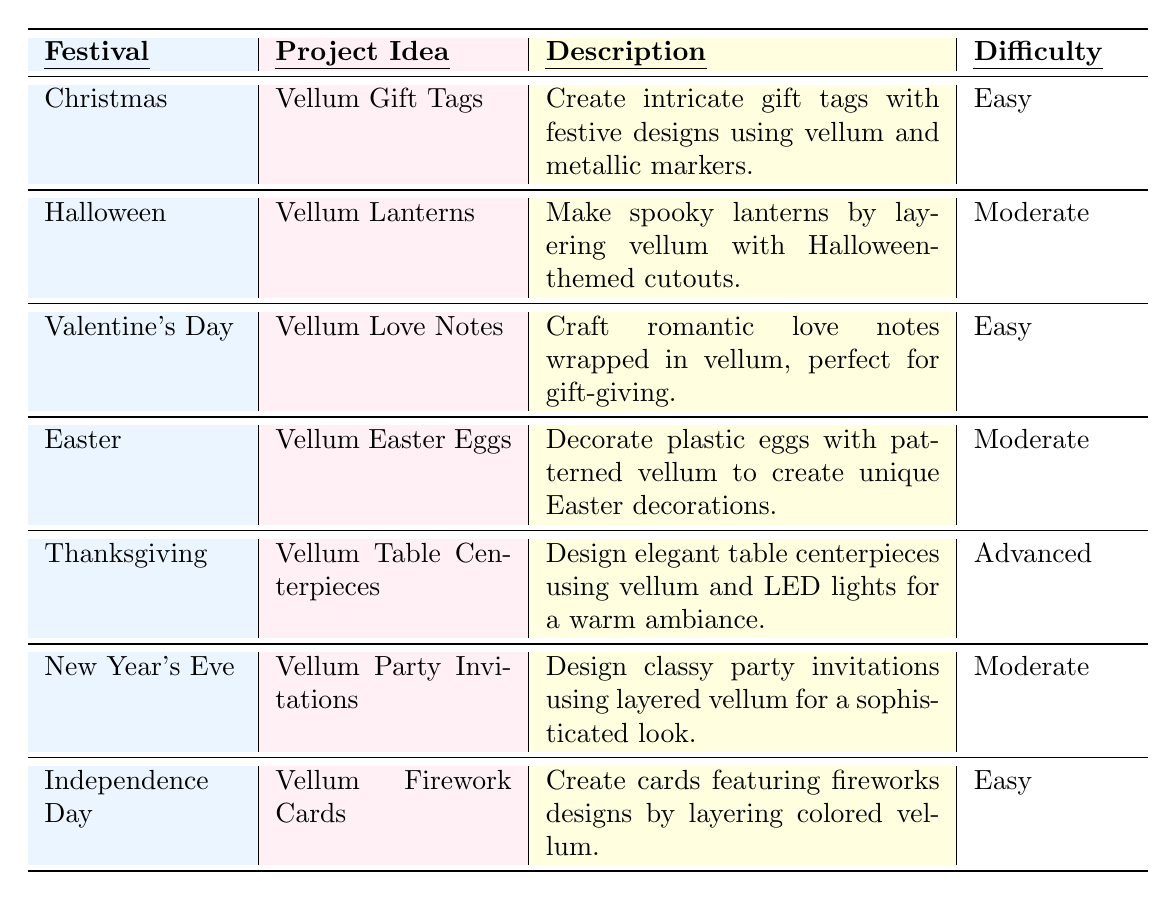What is the project idea for Christmas? The table lists "Vellum Gift Tags" as the project idea for Christmas.
Answer: Vellum Gift Tags Which festival has an advanced difficulty level project? The only project listed with an advanced difficulty level is "Vellum Table Centerpieces" for Thanksgiving.
Answer: Thanksgiving What materials are needed for Vellum Love Notes? The materials listed for Vellum Love Notes are colored vellum, cardstock, embellishments, and glue.
Answer: Colored vellum, cardstock, embellishments, glue How many projects are classified as easy? There are three projects classified as easy: Vellum Gift Tags for Christmas, Vellum Love Notes for Valentine's Day, and Vellum Firework Cards for Independence Day. So the count is 3.
Answer: 3 Is Halloween associated with an easy project? No, Halloween is associated with "Vellum Lanterns," which has a moderate difficulty level.
Answer: No Which festival involves decorating plastic eggs? The project involving decorating plastic eggs is "Vellum Easter Eggs," associated with Easter.
Answer: Easter What is the primary purpose of Vellum Firework Cards? The primary purpose of Vellum Firework Cards is to create cards featuring fireworks designs by layering colored vellum.
Answer: Create cards featuring fireworks designs If you wanted to make a project with a moderate difficulty level, how many choices do you have? There are three projects classified as moderate: Vellum Lanterns for Halloween, Vellum Easter Eggs for Easter, and Vellum Party Invitations for New Year's Eve. So the count is 3.
Answer: 3 What festival is associated with sophisticated party invitations? New Year's Eve is the festival associated with "Vellum Party Invitations," which are described as classy and sophisticated.
Answer: New Year's Eve Compare the materials required for Vellum Table Centerpieces and Vellum Gift Tags. Vellum Table Centerpieces require vellum, glass vases, LED tea lights, and fall-themed decorations. Vellum Gift Tags require vellum sheets, metallic pens, stamping tools, and twine. Both require vellum but have different additional materials.
Answer: Different materials Which project allows the use of metallic markers? The project "Vellum Gift Tags" allows the use of metallic markers for creating intricate gift tags.
Answer: Vellum Gift Tags 